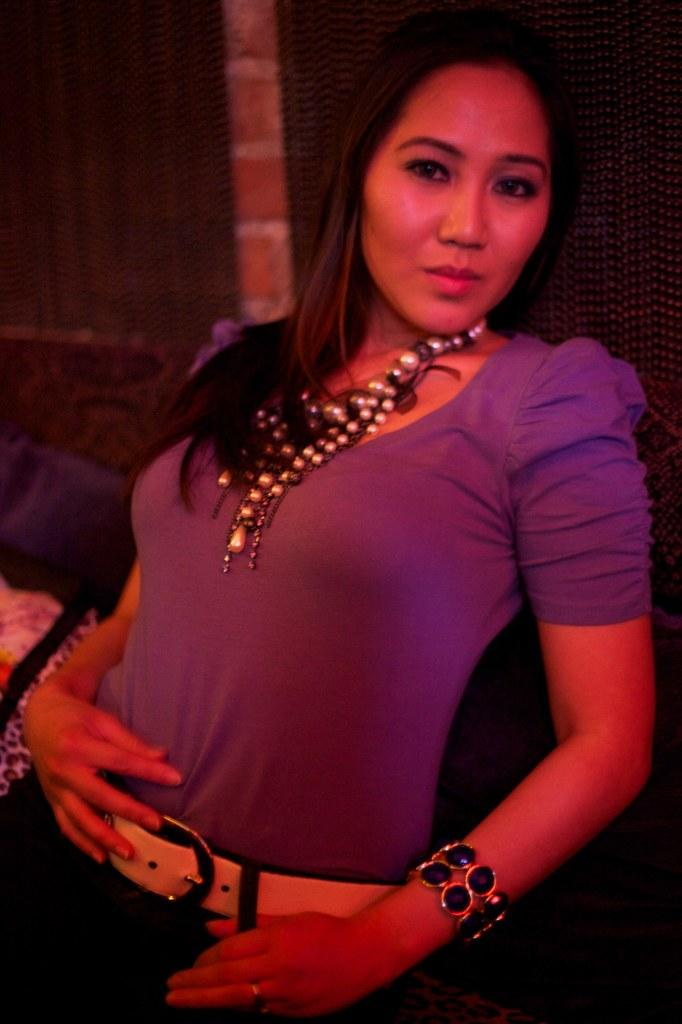Who is present in the image? There is a woman in the image. What direction is the woman facing in the image? The provided facts do not mention the direction the woman is facing, so it cannot be determined from the image. What impulse might have led the woman to be in the image? The provided facts do not mention any impulses or reasons for the woman's presence in the image, so it cannot be determined from the image. Is there a ray of light visible in the image? The provided facts do not mention any rays of light in the image, so it cannot be determined from the image. 